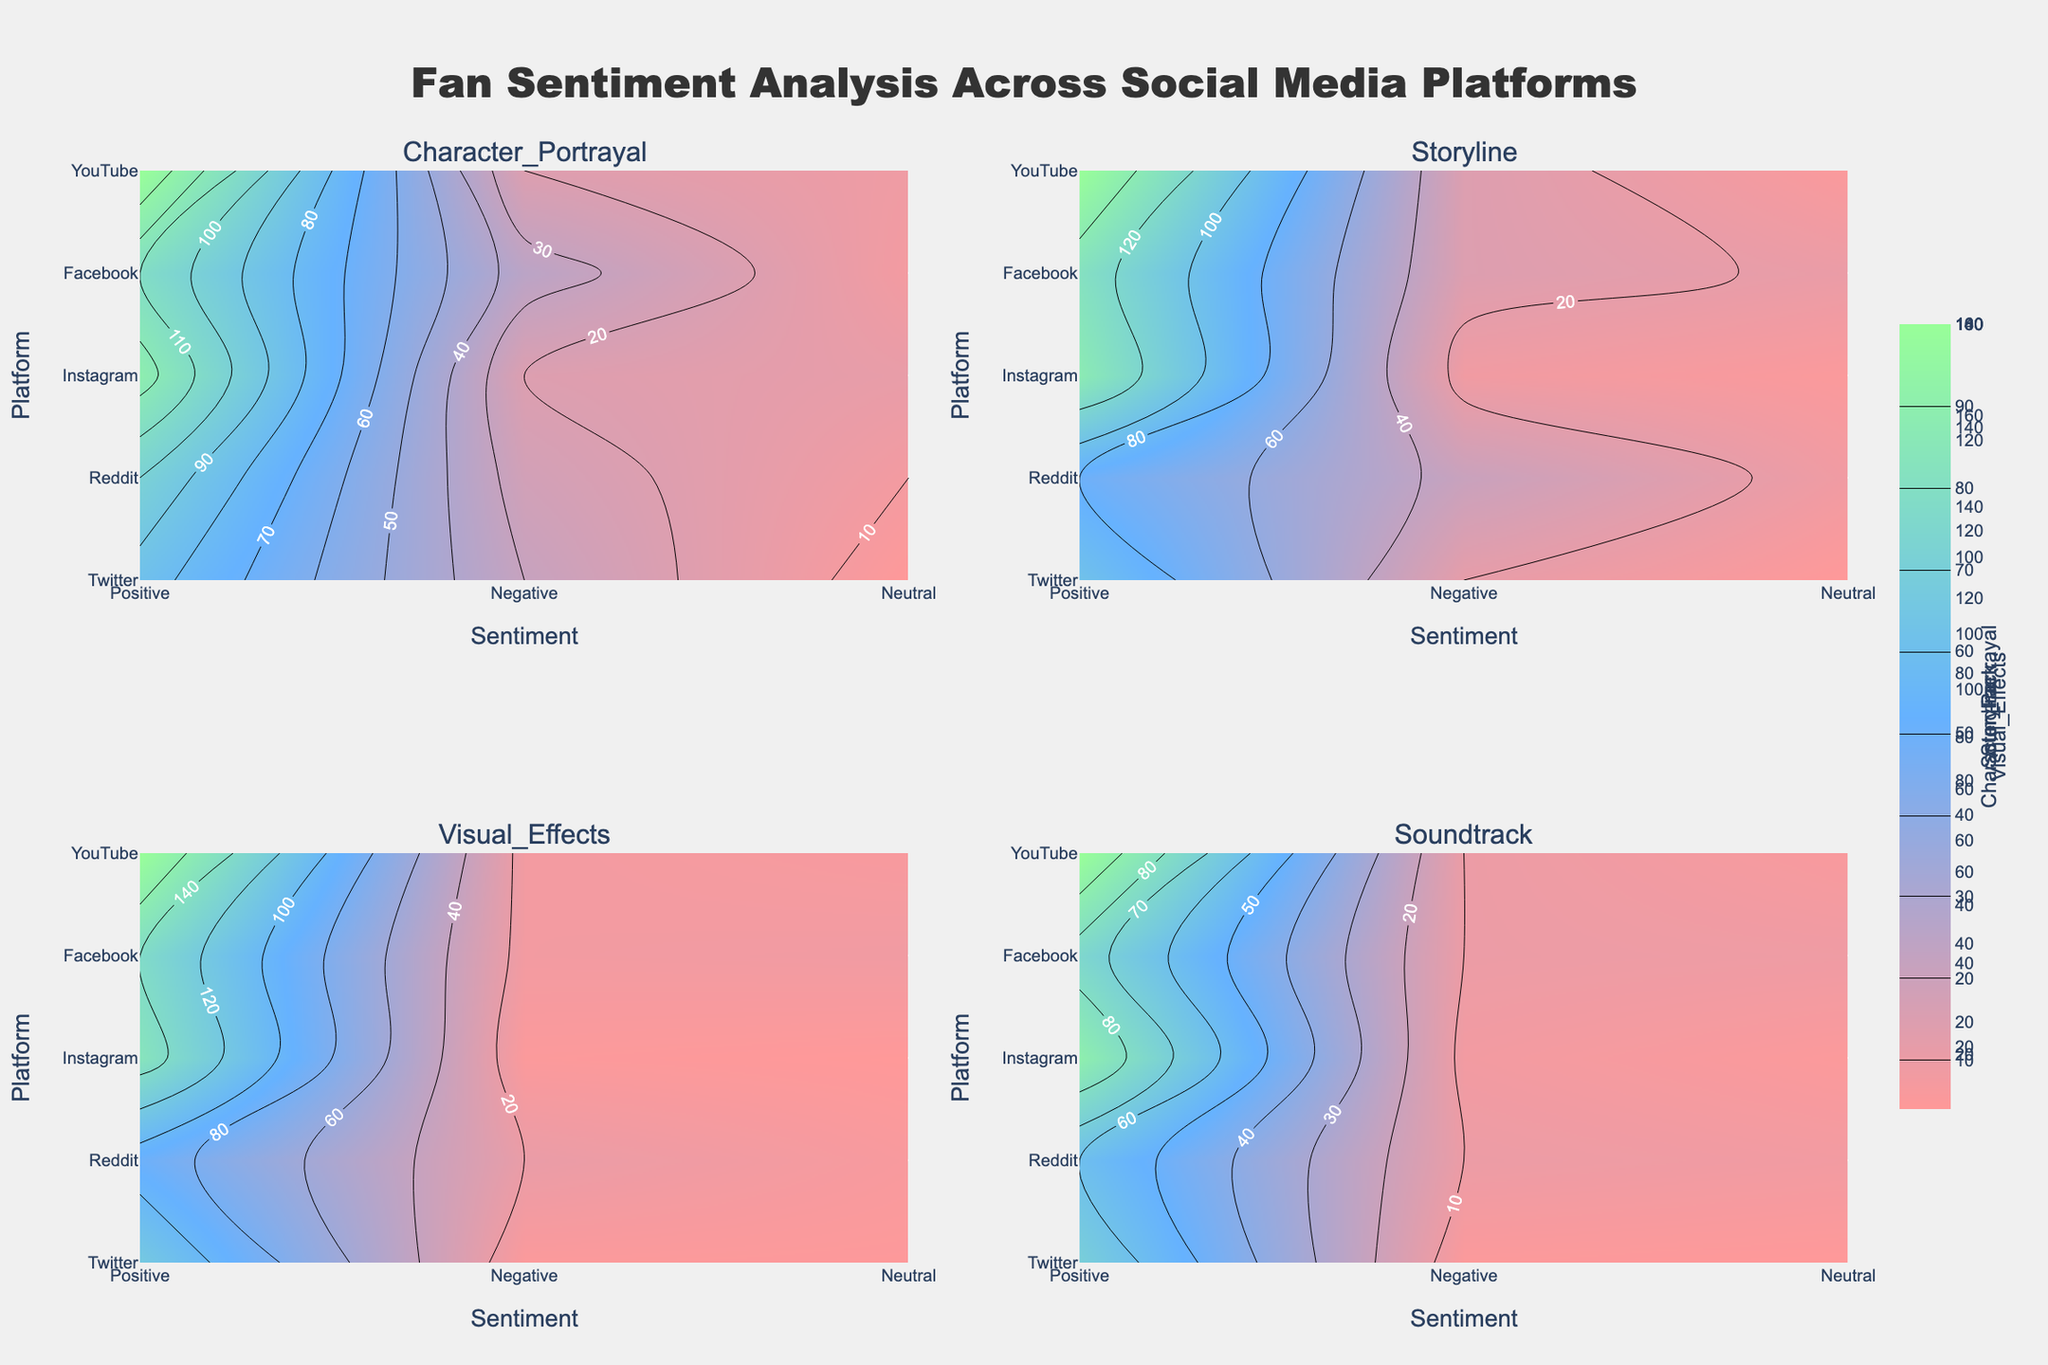What's the title of the figure? The title is generally located at the top of the figure and provides a summary of the visual data presented.
Answer: Fan Sentiment Analysis Across Social Media Platforms Which platforms have the highest number of positive reviews? Look for the highest values in the heatmap for positive sentiment across all subplots. Check each subplot title if necessary.
Answer: YouTube and Instagram What aspect has the most consistent negative sentiment across all platforms? Determine which subplot corresponds to each aspect and compare the values for negative sentiment across platforms within each subplot.
Answer: Character_Portrayal How does Twitter's neutral sentiment for the Storyline compare with other platforms? Locate the subplot for Storyline and compare the z-values for neutral sentiment across Twitter versus other platforms.
Answer: Relatively low Which aspect shows the highest variability in positive sentiment among different platforms? Assess the range of values for positive sentiment within each subplot to determine where the largest spread occurs.
Answer: Visual_Effects Is there a platform where the sentiment for the Soundtrack is predominantly positive? Observe the z-values in the Soundtrack subplot and identify if the positive sentiment values are generally higher across the platforms.
Answer: YouTube Comparing Facebook and Reddit, which platform has a higher neutral sentiment for Character Portrayal? Look at the values in the Character_Portrayal subplot for neutral sentiment and compare the z-values for Facebook and Reddit.
Answer: Facebook What is the color scale used in the figure? The color scale is depicted along the contour lines and differs for various sentiment levels, usually shown in a legend or color bar.
Answer: Shades of red, blue, and green Which sentiment does Instagram score lowest for Visual Effects, and what is that score? Examine the z-values for Instagram in the Visual_Effects subplot and identify the lowest value and corresponding sentiment.
Answer: Negative, 15 Which platform has the least variability in sentiment for Storyline? Compare the range of z-values across all sentiments for each platform within the Storyline subplot to find the least spread.
Answer: Instagram 